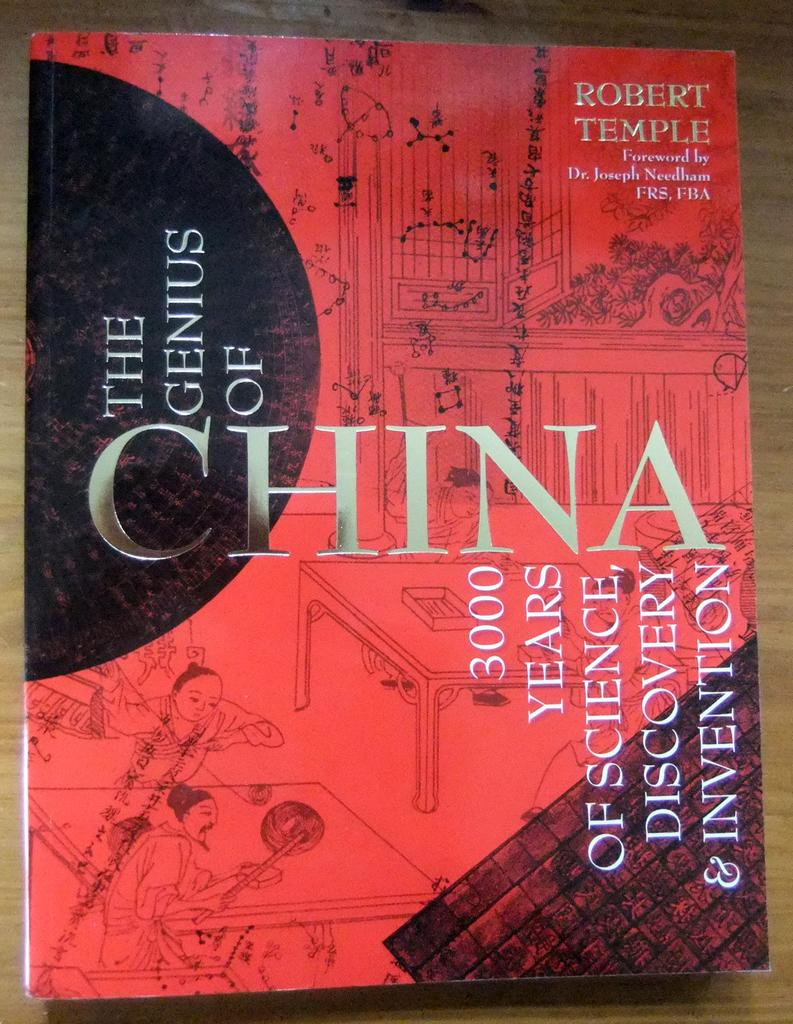<image>
Provide a brief description of the given image. The artistic red and black cover if The Genius of China by Robert Temple. 